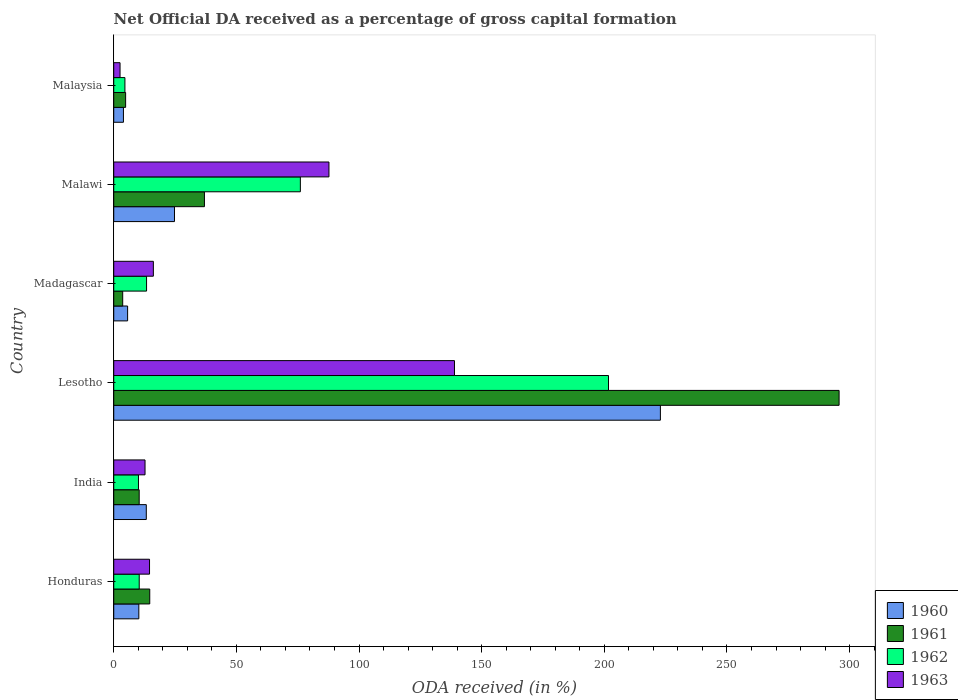How many groups of bars are there?
Your response must be concise. 6. Are the number of bars per tick equal to the number of legend labels?
Keep it short and to the point. Yes. How many bars are there on the 2nd tick from the top?
Provide a short and direct response. 4. What is the label of the 3rd group of bars from the top?
Your answer should be very brief. Madagascar. What is the net ODA received in 1962 in Malawi?
Provide a short and direct response. 76.08. Across all countries, what is the maximum net ODA received in 1963?
Provide a succinct answer. 138.92. Across all countries, what is the minimum net ODA received in 1961?
Make the answer very short. 3.65. In which country was the net ODA received in 1962 maximum?
Give a very brief answer. Lesotho. In which country was the net ODA received in 1961 minimum?
Ensure brevity in your answer.  Madagascar. What is the total net ODA received in 1960 in the graph?
Keep it short and to the point. 280.72. What is the difference between the net ODA received in 1960 in Lesotho and that in Malaysia?
Give a very brief answer. 218.91. What is the difference between the net ODA received in 1962 in Malaysia and the net ODA received in 1960 in Lesotho?
Your answer should be compact. -218.3. What is the average net ODA received in 1962 per country?
Offer a very short reply. 52.7. What is the difference between the net ODA received in 1961 and net ODA received in 1962 in Lesotho?
Offer a very short reply. 94.01. What is the ratio of the net ODA received in 1963 in Honduras to that in India?
Your response must be concise. 1.14. Is the net ODA received in 1962 in India less than that in Madagascar?
Provide a short and direct response. Yes. What is the difference between the highest and the second highest net ODA received in 1961?
Give a very brief answer. 258.74. What is the difference between the highest and the lowest net ODA received in 1960?
Make the answer very short. 218.91. Is the sum of the net ODA received in 1960 in Honduras and India greater than the maximum net ODA received in 1961 across all countries?
Make the answer very short. No. Is it the case that in every country, the sum of the net ODA received in 1961 and net ODA received in 1962 is greater than the sum of net ODA received in 1960 and net ODA received in 1963?
Provide a succinct answer. No. Is it the case that in every country, the sum of the net ODA received in 1962 and net ODA received in 1961 is greater than the net ODA received in 1963?
Offer a very short reply. Yes. How many countries are there in the graph?
Make the answer very short. 6. Where does the legend appear in the graph?
Ensure brevity in your answer.  Bottom right. How many legend labels are there?
Keep it short and to the point. 4. How are the legend labels stacked?
Offer a terse response. Vertical. What is the title of the graph?
Provide a short and direct response. Net Official DA received as a percentage of gross capital formation. Does "1971" appear as one of the legend labels in the graph?
Your answer should be very brief. No. What is the label or title of the X-axis?
Make the answer very short. ODA received (in %). What is the label or title of the Y-axis?
Your answer should be compact. Country. What is the ODA received (in %) of 1960 in Honduras?
Give a very brief answer. 10.23. What is the ODA received (in %) in 1961 in Honduras?
Offer a very short reply. 14.68. What is the ODA received (in %) in 1962 in Honduras?
Make the answer very short. 10.39. What is the ODA received (in %) of 1963 in Honduras?
Your answer should be very brief. 14.59. What is the ODA received (in %) in 1960 in India?
Offer a terse response. 13.27. What is the ODA received (in %) in 1961 in India?
Ensure brevity in your answer.  10.37. What is the ODA received (in %) of 1962 in India?
Provide a short and direct response. 10.08. What is the ODA received (in %) of 1963 in India?
Provide a succinct answer. 12.76. What is the ODA received (in %) of 1960 in Lesotho?
Keep it short and to the point. 222.86. What is the ODA received (in %) in 1961 in Lesotho?
Ensure brevity in your answer.  295.71. What is the ODA received (in %) of 1962 in Lesotho?
Ensure brevity in your answer.  201.7. What is the ODA received (in %) of 1963 in Lesotho?
Your answer should be very brief. 138.92. What is the ODA received (in %) of 1960 in Madagascar?
Give a very brief answer. 5.66. What is the ODA received (in %) of 1961 in Madagascar?
Provide a short and direct response. 3.65. What is the ODA received (in %) in 1962 in Madagascar?
Provide a succinct answer. 13.38. What is the ODA received (in %) of 1963 in Madagascar?
Your answer should be compact. 16.15. What is the ODA received (in %) of 1960 in Malawi?
Your answer should be compact. 24.76. What is the ODA received (in %) of 1961 in Malawi?
Offer a terse response. 36.97. What is the ODA received (in %) of 1962 in Malawi?
Your answer should be very brief. 76.08. What is the ODA received (in %) in 1963 in Malawi?
Provide a short and direct response. 87.74. What is the ODA received (in %) in 1960 in Malaysia?
Provide a succinct answer. 3.95. What is the ODA received (in %) of 1961 in Malaysia?
Your answer should be compact. 4.84. What is the ODA received (in %) in 1962 in Malaysia?
Offer a terse response. 4.56. What is the ODA received (in %) of 1963 in Malaysia?
Your answer should be very brief. 2.57. Across all countries, what is the maximum ODA received (in %) in 1960?
Your response must be concise. 222.86. Across all countries, what is the maximum ODA received (in %) in 1961?
Provide a short and direct response. 295.71. Across all countries, what is the maximum ODA received (in %) in 1962?
Offer a very short reply. 201.7. Across all countries, what is the maximum ODA received (in %) of 1963?
Give a very brief answer. 138.92. Across all countries, what is the minimum ODA received (in %) of 1960?
Your response must be concise. 3.95. Across all countries, what is the minimum ODA received (in %) of 1961?
Ensure brevity in your answer.  3.65. Across all countries, what is the minimum ODA received (in %) of 1962?
Ensure brevity in your answer.  4.56. Across all countries, what is the minimum ODA received (in %) of 1963?
Keep it short and to the point. 2.57. What is the total ODA received (in %) in 1960 in the graph?
Make the answer very short. 280.72. What is the total ODA received (in %) in 1961 in the graph?
Your answer should be very brief. 366.23. What is the total ODA received (in %) in 1962 in the graph?
Your response must be concise. 316.19. What is the total ODA received (in %) in 1963 in the graph?
Make the answer very short. 272.73. What is the difference between the ODA received (in %) in 1960 in Honduras and that in India?
Keep it short and to the point. -3.05. What is the difference between the ODA received (in %) in 1961 in Honduras and that in India?
Provide a short and direct response. 4.3. What is the difference between the ODA received (in %) of 1962 in Honduras and that in India?
Make the answer very short. 0.31. What is the difference between the ODA received (in %) in 1963 in Honduras and that in India?
Your response must be concise. 1.84. What is the difference between the ODA received (in %) in 1960 in Honduras and that in Lesotho?
Offer a very short reply. -212.63. What is the difference between the ODA received (in %) in 1961 in Honduras and that in Lesotho?
Keep it short and to the point. -281.04. What is the difference between the ODA received (in %) of 1962 in Honduras and that in Lesotho?
Provide a short and direct response. -191.31. What is the difference between the ODA received (in %) of 1963 in Honduras and that in Lesotho?
Your answer should be very brief. -124.33. What is the difference between the ODA received (in %) in 1960 in Honduras and that in Madagascar?
Your answer should be compact. 4.57. What is the difference between the ODA received (in %) in 1961 in Honduras and that in Madagascar?
Your answer should be compact. 11.03. What is the difference between the ODA received (in %) in 1962 in Honduras and that in Madagascar?
Provide a succinct answer. -2.99. What is the difference between the ODA received (in %) in 1963 in Honduras and that in Madagascar?
Give a very brief answer. -1.56. What is the difference between the ODA received (in %) in 1960 in Honduras and that in Malawi?
Give a very brief answer. -14.54. What is the difference between the ODA received (in %) of 1961 in Honduras and that in Malawi?
Make the answer very short. -22.29. What is the difference between the ODA received (in %) in 1962 in Honduras and that in Malawi?
Give a very brief answer. -65.69. What is the difference between the ODA received (in %) in 1963 in Honduras and that in Malawi?
Your answer should be compact. -73.15. What is the difference between the ODA received (in %) of 1960 in Honduras and that in Malaysia?
Your answer should be very brief. 6.27. What is the difference between the ODA received (in %) of 1961 in Honduras and that in Malaysia?
Provide a short and direct response. 9.83. What is the difference between the ODA received (in %) of 1962 in Honduras and that in Malaysia?
Make the answer very short. 5.83. What is the difference between the ODA received (in %) of 1963 in Honduras and that in Malaysia?
Provide a short and direct response. 12.02. What is the difference between the ODA received (in %) of 1960 in India and that in Lesotho?
Ensure brevity in your answer.  -209.59. What is the difference between the ODA received (in %) of 1961 in India and that in Lesotho?
Give a very brief answer. -285.34. What is the difference between the ODA received (in %) in 1962 in India and that in Lesotho?
Keep it short and to the point. -191.62. What is the difference between the ODA received (in %) in 1963 in India and that in Lesotho?
Make the answer very short. -126.16. What is the difference between the ODA received (in %) in 1960 in India and that in Madagascar?
Give a very brief answer. 7.62. What is the difference between the ODA received (in %) in 1961 in India and that in Madagascar?
Provide a succinct answer. 6.72. What is the difference between the ODA received (in %) of 1962 in India and that in Madagascar?
Provide a succinct answer. -3.3. What is the difference between the ODA received (in %) of 1963 in India and that in Madagascar?
Make the answer very short. -3.4. What is the difference between the ODA received (in %) in 1960 in India and that in Malawi?
Your response must be concise. -11.49. What is the difference between the ODA received (in %) of 1961 in India and that in Malawi?
Provide a succinct answer. -26.6. What is the difference between the ODA received (in %) of 1962 in India and that in Malawi?
Keep it short and to the point. -66. What is the difference between the ODA received (in %) in 1963 in India and that in Malawi?
Your answer should be compact. -74.98. What is the difference between the ODA received (in %) in 1960 in India and that in Malaysia?
Your response must be concise. 9.32. What is the difference between the ODA received (in %) of 1961 in India and that in Malaysia?
Provide a succinct answer. 5.53. What is the difference between the ODA received (in %) in 1962 in India and that in Malaysia?
Make the answer very short. 5.52. What is the difference between the ODA received (in %) of 1963 in India and that in Malaysia?
Ensure brevity in your answer.  10.19. What is the difference between the ODA received (in %) of 1960 in Lesotho and that in Madagascar?
Offer a very short reply. 217.2. What is the difference between the ODA received (in %) of 1961 in Lesotho and that in Madagascar?
Offer a very short reply. 292.06. What is the difference between the ODA received (in %) in 1962 in Lesotho and that in Madagascar?
Offer a terse response. 188.32. What is the difference between the ODA received (in %) in 1963 in Lesotho and that in Madagascar?
Provide a short and direct response. 122.76. What is the difference between the ODA received (in %) in 1960 in Lesotho and that in Malawi?
Your answer should be very brief. 198.1. What is the difference between the ODA received (in %) in 1961 in Lesotho and that in Malawi?
Make the answer very short. 258.74. What is the difference between the ODA received (in %) in 1962 in Lesotho and that in Malawi?
Give a very brief answer. 125.62. What is the difference between the ODA received (in %) of 1963 in Lesotho and that in Malawi?
Ensure brevity in your answer.  51.18. What is the difference between the ODA received (in %) of 1960 in Lesotho and that in Malaysia?
Provide a short and direct response. 218.91. What is the difference between the ODA received (in %) in 1961 in Lesotho and that in Malaysia?
Provide a short and direct response. 290.87. What is the difference between the ODA received (in %) of 1962 in Lesotho and that in Malaysia?
Offer a terse response. 197.14. What is the difference between the ODA received (in %) in 1963 in Lesotho and that in Malaysia?
Offer a very short reply. 136.35. What is the difference between the ODA received (in %) in 1960 in Madagascar and that in Malawi?
Provide a short and direct response. -19.11. What is the difference between the ODA received (in %) in 1961 in Madagascar and that in Malawi?
Offer a terse response. -33.32. What is the difference between the ODA received (in %) in 1962 in Madagascar and that in Malawi?
Provide a short and direct response. -62.7. What is the difference between the ODA received (in %) in 1963 in Madagascar and that in Malawi?
Ensure brevity in your answer.  -71.59. What is the difference between the ODA received (in %) of 1960 in Madagascar and that in Malaysia?
Ensure brevity in your answer.  1.7. What is the difference between the ODA received (in %) in 1961 in Madagascar and that in Malaysia?
Provide a succinct answer. -1.19. What is the difference between the ODA received (in %) in 1962 in Madagascar and that in Malaysia?
Give a very brief answer. 8.82. What is the difference between the ODA received (in %) of 1963 in Madagascar and that in Malaysia?
Your answer should be very brief. 13.59. What is the difference between the ODA received (in %) in 1960 in Malawi and that in Malaysia?
Offer a very short reply. 20.81. What is the difference between the ODA received (in %) in 1961 in Malawi and that in Malaysia?
Give a very brief answer. 32.13. What is the difference between the ODA received (in %) in 1962 in Malawi and that in Malaysia?
Your answer should be very brief. 71.52. What is the difference between the ODA received (in %) of 1963 in Malawi and that in Malaysia?
Your answer should be compact. 85.17. What is the difference between the ODA received (in %) of 1960 in Honduras and the ODA received (in %) of 1961 in India?
Offer a terse response. -0.15. What is the difference between the ODA received (in %) of 1960 in Honduras and the ODA received (in %) of 1962 in India?
Your answer should be very brief. 0.14. What is the difference between the ODA received (in %) in 1960 in Honduras and the ODA received (in %) in 1963 in India?
Your answer should be very brief. -2.53. What is the difference between the ODA received (in %) of 1961 in Honduras and the ODA received (in %) of 1962 in India?
Offer a terse response. 4.6. What is the difference between the ODA received (in %) of 1961 in Honduras and the ODA received (in %) of 1963 in India?
Offer a very short reply. 1.92. What is the difference between the ODA received (in %) in 1962 in Honduras and the ODA received (in %) in 1963 in India?
Your answer should be very brief. -2.37. What is the difference between the ODA received (in %) in 1960 in Honduras and the ODA received (in %) in 1961 in Lesotho?
Give a very brief answer. -285.49. What is the difference between the ODA received (in %) of 1960 in Honduras and the ODA received (in %) of 1962 in Lesotho?
Offer a terse response. -191.48. What is the difference between the ODA received (in %) in 1960 in Honduras and the ODA received (in %) in 1963 in Lesotho?
Give a very brief answer. -128.69. What is the difference between the ODA received (in %) in 1961 in Honduras and the ODA received (in %) in 1962 in Lesotho?
Provide a short and direct response. -187.02. What is the difference between the ODA received (in %) of 1961 in Honduras and the ODA received (in %) of 1963 in Lesotho?
Your answer should be very brief. -124.24. What is the difference between the ODA received (in %) of 1962 in Honduras and the ODA received (in %) of 1963 in Lesotho?
Provide a succinct answer. -128.53. What is the difference between the ODA received (in %) in 1960 in Honduras and the ODA received (in %) in 1961 in Madagascar?
Provide a succinct answer. 6.57. What is the difference between the ODA received (in %) in 1960 in Honduras and the ODA received (in %) in 1962 in Madagascar?
Your answer should be compact. -3.16. What is the difference between the ODA received (in %) of 1960 in Honduras and the ODA received (in %) of 1963 in Madagascar?
Your response must be concise. -5.93. What is the difference between the ODA received (in %) in 1961 in Honduras and the ODA received (in %) in 1962 in Madagascar?
Ensure brevity in your answer.  1.3. What is the difference between the ODA received (in %) in 1961 in Honduras and the ODA received (in %) in 1963 in Madagascar?
Keep it short and to the point. -1.48. What is the difference between the ODA received (in %) in 1962 in Honduras and the ODA received (in %) in 1963 in Madagascar?
Provide a short and direct response. -5.76. What is the difference between the ODA received (in %) in 1960 in Honduras and the ODA received (in %) in 1961 in Malawi?
Keep it short and to the point. -26.75. What is the difference between the ODA received (in %) in 1960 in Honduras and the ODA received (in %) in 1962 in Malawi?
Ensure brevity in your answer.  -65.86. What is the difference between the ODA received (in %) in 1960 in Honduras and the ODA received (in %) in 1963 in Malawi?
Your answer should be compact. -77.51. What is the difference between the ODA received (in %) of 1961 in Honduras and the ODA received (in %) of 1962 in Malawi?
Give a very brief answer. -61.4. What is the difference between the ODA received (in %) in 1961 in Honduras and the ODA received (in %) in 1963 in Malawi?
Offer a terse response. -73.06. What is the difference between the ODA received (in %) in 1962 in Honduras and the ODA received (in %) in 1963 in Malawi?
Provide a short and direct response. -77.35. What is the difference between the ODA received (in %) in 1960 in Honduras and the ODA received (in %) in 1961 in Malaysia?
Ensure brevity in your answer.  5.38. What is the difference between the ODA received (in %) of 1960 in Honduras and the ODA received (in %) of 1962 in Malaysia?
Offer a very short reply. 5.66. What is the difference between the ODA received (in %) in 1960 in Honduras and the ODA received (in %) in 1963 in Malaysia?
Ensure brevity in your answer.  7.66. What is the difference between the ODA received (in %) of 1961 in Honduras and the ODA received (in %) of 1962 in Malaysia?
Provide a succinct answer. 10.12. What is the difference between the ODA received (in %) of 1961 in Honduras and the ODA received (in %) of 1963 in Malaysia?
Make the answer very short. 12.11. What is the difference between the ODA received (in %) of 1962 in Honduras and the ODA received (in %) of 1963 in Malaysia?
Your response must be concise. 7.82. What is the difference between the ODA received (in %) of 1960 in India and the ODA received (in %) of 1961 in Lesotho?
Your answer should be very brief. -282.44. What is the difference between the ODA received (in %) in 1960 in India and the ODA received (in %) in 1962 in Lesotho?
Give a very brief answer. -188.43. What is the difference between the ODA received (in %) of 1960 in India and the ODA received (in %) of 1963 in Lesotho?
Provide a short and direct response. -125.65. What is the difference between the ODA received (in %) in 1961 in India and the ODA received (in %) in 1962 in Lesotho?
Make the answer very short. -191.33. What is the difference between the ODA received (in %) of 1961 in India and the ODA received (in %) of 1963 in Lesotho?
Give a very brief answer. -128.54. What is the difference between the ODA received (in %) in 1962 in India and the ODA received (in %) in 1963 in Lesotho?
Offer a very short reply. -128.84. What is the difference between the ODA received (in %) in 1960 in India and the ODA received (in %) in 1961 in Madagascar?
Provide a succinct answer. 9.62. What is the difference between the ODA received (in %) in 1960 in India and the ODA received (in %) in 1962 in Madagascar?
Ensure brevity in your answer.  -0.11. What is the difference between the ODA received (in %) in 1960 in India and the ODA received (in %) in 1963 in Madagascar?
Give a very brief answer. -2.88. What is the difference between the ODA received (in %) of 1961 in India and the ODA received (in %) of 1962 in Madagascar?
Make the answer very short. -3.01. What is the difference between the ODA received (in %) in 1961 in India and the ODA received (in %) in 1963 in Madagascar?
Ensure brevity in your answer.  -5.78. What is the difference between the ODA received (in %) of 1962 in India and the ODA received (in %) of 1963 in Madagascar?
Provide a succinct answer. -6.07. What is the difference between the ODA received (in %) of 1960 in India and the ODA received (in %) of 1961 in Malawi?
Ensure brevity in your answer.  -23.7. What is the difference between the ODA received (in %) in 1960 in India and the ODA received (in %) in 1962 in Malawi?
Your answer should be compact. -62.81. What is the difference between the ODA received (in %) of 1960 in India and the ODA received (in %) of 1963 in Malawi?
Your response must be concise. -74.47. What is the difference between the ODA received (in %) of 1961 in India and the ODA received (in %) of 1962 in Malawi?
Your answer should be very brief. -65.71. What is the difference between the ODA received (in %) in 1961 in India and the ODA received (in %) in 1963 in Malawi?
Make the answer very short. -77.37. What is the difference between the ODA received (in %) of 1962 in India and the ODA received (in %) of 1963 in Malawi?
Offer a terse response. -77.66. What is the difference between the ODA received (in %) of 1960 in India and the ODA received (in %) of 1961 in Malaysia?
Ensure brevity in your answer.  8.43. What is the difference between the ODA received (in %) of 1960 in India and the ODA received (in %) of 1962 in Malaysia?
Your answer should be very brief. 8.71. What is the difference between the ODA received (in %) of 1960 in India and the ODA received (in %) of 1963 in Malaysia?
Your answer should be very brief. 10.7. What is the difference between the ODA received (in %) in 1961 in India and the ODA received (in %) in 1962 in Malaysia?
Your answer should be very brief. 5.81. What is the difference between the ODA received (in %) in 1961 in India and the ODA received (in %) in 1963 in Malaysia?
Ensure brevity in your answer.  7.8. What is the difference between the ODA received (in %) of 1962 in India and the ODA received (in %) of 1963 in Malaysia?
Make the answer very short. 7.51. What is the difference between the ODA received (in %) in 1960 in Lesotho and the ODA received (in %) in 1961 in Madagascar?
Ensure brevity in your answer.  219.21. What is the difference between the ODA received (in %) in 1960 in Lesotho and the ODA received (in %) in 1962 in Madagascar?
Your answer should be very brief. 209.48. What is the difference between the ODA received (in %) in 1960 in Lesotho and the ODA received (in %) in 1963 in Madagascar?
Your answer should be very brief. 206.7. What is the difference between the ODA received (in %) of 1961 in Lesotho and the ODA received (in %) of 1962 in Madagascar?
Provide a succinct answer. 282.33. What is the difference between the ODA received (in %) in 1961 in Lesotho and the ODA received (in %) in 1963 in Madagascar?
Make the answer very short. 279.56. What is the difference between the ODA received (in %) in 1962 in Lesotho and the ODA received (in %) in 1963 in Madagascar?
Your answer should be compact. 185.55. What is the difference between the ODA received (in %) of 1960 in Lesotho and the ODA received (in %) of 1961 in Malawi?
Give a very brief answer. 185.89. What is the difference between the ODA received (in %) of 1960 in Lesotho and the ODA received (in %) of 1962 in Malawi?
Your response must be concise. 146.78. What is the difference between the ODA received (in %) of 1960 in Lesotho and the ODA received (in %) of 1963 in Malawi?
Offer a very short reply. 135.12. What is the difference between the ODA received (in %) of 1961 in Lesotho and the ODA received (in %) of 1962 in Malawi?
Provide a short and direct response. 219.63. What is the difference between the ODA received (in %) in 1961 in Lesotho and the ODA received (in %) in 1963 in Malawi?
Make the answer very short. 207.97. What is the difference between the ODA received (in %) of 1962 in Lesotho and the ODA received (in %) of 1963 in Malawi?
Offer a terse response. 113.96. What is the difference between the ODA received (in %) of 1960 in Lesotho and the ODA received (in %) of 1961 in Malaysia?
Provide a short and direct response. 218.01. What is the difference between the ODA received (in %) in 1960 in Lesotho and the ODA received (in %) in 1962 in Malaysia?
Offer a very short reply. 218.3. What is the difference between the ODA received (in %) in 1960 in Lesotho and the ODA received (in %) in 1963 in Malaysia?
Keep it short and to the point. 220.29. What is the difference between the ODA received (in %) in 1961 in Lesotho and the ODA received (in %) in 1962 in Malaysia?
Provide a succinct answer. 291.15. What is the difference between the ODA received (in %) of 1961 in Lesotho and the ODA received (in %) of 1963 in Malaysia?
Your answer should be very brief. 293.15. What is the difference between the ODA received (in %) of 1962 in Lesotho and the ODA received (in %) of 1963 in Malaysia?
Make the answer very short. 199.13. What is the difference between the ODA received (in %) in 1960 in Madagascar and the ODA received (in %) in 1961 in Malawi?
Offer a very short reply. -31.32. What is the difference between the ODA received (in %) of 1960 in Madagascar and the ODA received (in %) of 1962 in Malawi?
Provide a short and direct response. -70.43. What is the difference between the ODA received (in %) in 1960 in Madagascar and the ODA received (in %) in 1963 in Malawi?
Offer a terse response. -82.08. What is the difference between the ODA received (in %) in 1961 in Madagascar and the ODA received (in %) in 1962 in Malawi?
Your answer should be compact. -72.43. What is the difference between the ODA received (in %) of 1961 in Madagascar and the ODA received (in %) of 1963 in Malawi?
Your response must be concise. -84.09. What is the difference between the ODA received (in %) in 1962 in Madagascar and the ODA received (in %) in 1963 in Malawi?
Your answer should be very brief. -74.36. What is the difference between the ODA received (in %) in 1960 in Madagascar and the ODA received (in %) in 1961 in Malaysia?
Provide a succinct answer. 0.81. What is the difference between the ODA received (in %) of 1960 in Madagascar and the ODA received (in %) of 1962 in Malaysia?
Your answer should be very brief. 1.09. What is the difference between the ODA received (in %) of 1960 in Madagascar and the ODA received (in %) of 1963 in Malaysia?
Offer a terse response. 3.09. What is the difference between the ODA received (in %) in 1961 in Madagascar and the ODA received (in %) in 1962 in Malaysia?
Provide a succinct answer. -0.91. What is the difference between the ODA received (in %) of 1961 in Madagascar and the ODA received (in %) of 1963 in Malaysia?
Your answer should be very brief. 1.08. What is the difference between the ODA received (in %) in 1962 in Madagascar and the ODA received (in %) in 1963 in Malaysia?
Keep it short and to the point. 10.81. What is the difference between the ODA received (in %) in 1960 in Malawi and the ODA received (in %) in 1961 in Malaysia?
Offer a very short reply. 19.92. What is the difference between the ODA received (in %) in 1960 in Malawi and the ODA received (in %) in 1962 in Malaysia?
Ensure brevity in your answer.  20.2. What is the difference between the ODA received (in %) of 1960 in Malawi and the ODA received (in %) of 1963 in Malaysia?
Your response must be concise. 22.19. What is the difference between the ODA received (in %) in 1961 in Malawi and the ODA received (in %) in 1962 in Malaysia?
Your response must be concise. 32.41. What is the difference between the ODA received (in %) in 1961 in Malawi and the ODA received (in %) in 1963 in Malaysia?
Make the answer very short. 34.4. What is the difference between the ODA received (in %) of 1962 in Malawi and the ODA received (in %) of 1963 in Malaysia?
Ensure brevity in your answer.  73.51. What is the average ODA received (in %) in 1960 per country?
Keep it short and to the point. 46.79. What is the average ODA received (in %) in 1961 per country?
Keep it short and to the point. 61.04. What is the average ODA received (in %) in 1962 per country?
Provide a short and direct response. 52.7. What is the average ODA received (in %) in 1963 per country?
Make the answer very short. 45.45. What is the difference between the ODA received (in %) of 1960 and ODA received (in %) of 1961 in Honduras?
Keep it short and to the point. -4.45. What is the difference between the ODA received (in %) of 1960 and ODA received (in %) of 1962 in Honduras?
Keep it short and to the point. -0.16. What is the difference between the ODA received (in %) of 1960 and ODA received (in %) of 1963 in Honduras?
Your answer should be very brief. -4.37. What is the difference between the ODA received (in %) in 1961 and ODA received (in %) in 1962 in Honduras?
Your answer should be compact. 4.29. What is the difference between the ODA received (in %) of 1961 and ODA received (in %) of 1963 in Honduras?
Provide a short and direct response. 0.09. What is the difference between the ODA received (in %) of 1962 and ODA received (in %) of 1963 in Honduras?
Your answer should be compact. -4.2. What is the difference between the ODA received (in %) of 1960 and ODA received (in %) of 1961 in India?
Offer a very short reply. 2.9. What is the difference between the ODA received (in %) in 1960 and ODA received (in %) in 1962 in India?
Keep it short and to the point. 3.19. What is the difference between the ODA received (in %) in 1960 and ODA received (in %) in 1963 in India?
Ensure brevity in your answer.  0.52. What is the difference between the ODA received (in %) of 1961 and ODA received (in %) of 1962 in India?
Provide a succinct answer. 0.29. What is the difference between the ODA received (in %) in 1961 and ODA received (in %) in 1963 in India?
Your answer should be compact. -2.38. What is the difference between the ODA received (in %) in 1962 and ODA received (in %) in 1963 in India?
Your answer should be compact. -2.68. What is the difference between the ODA received (in %) in 1960 and ODA received (in %) in 1961 in Lesotho?
Your response must be concise. -72.86. What is the difference between the ODA received (in %) of 1960 and ODA received (in %) of 1962 in Lesotho?
Ensure brevity in your answer.  21.16. What is the difference between the ODA received (in %) in 1960 and ODA received (in %) in 1963 in Lesotho?
Offer a very short reply. 83.94. What is the difference between the ODA received (in %) in 1961 and ODA received (in %) in 1962 in Lesotho?
Provide a succinct answer. 94.01. What is the difference between the ODA received (in %) of 1961 and ODA received (in %) of 1963 in Lesotho?
Provide a succinct answer. 156.8. What is the difference between the ODA received (in %) of 1962 and ODA received (in %) of 1963 in Lesotho?
Give a very brief answer. 62.78. What is the difference between the ODA received (in %) of 1960 and ODA received (in %) of 1961 in Madagascar?
Give a very brief answer. 2. What is the difference between the ODA received (in %) in 1960 and ODA received (in %) in 1962 in Madagascar?
Keep it short and to the point. -7.72. What is the difference between the ODA received (in %) of 1960 and ODA received (in %) of 1963 in Madagascar?
Offer a terse response. -10.5. What is the difference between the ODA received (in %) of 1961 and ODA received (in %) of 1962 in Madagascar?
Your answer should be compact. -9.73. What is the difference between the ODA received (in %) of 1961 and ODA received (in %) of 1963 in Madagascar?
Provide a short and direct response. -12.5. What is the difference between the ODA received (in %) in 1962 and ODA received (in %) in 1963 in Madagascar?
Keep it short and to the point. -2.77. What is the difference between the ODA received (in %) of 1960 and ODA received (in %) of 1961 in Malawi?
Offer a very short reply. -12.21. What is the difference between the ODA received (in %) of 1960 and ODA received (in %) of 1962 in Malawi?
Ensure brevity in your answer.  -51.32. What is the difference between the ODA received (in %) of 1960 and ODA received (in %) of 1963 in Malawi?
Offer a very short reply. -62.98. What is the difference between the ODA received (in %) of 1961 and ODA received (in %) of 1962 in Malawi?
Give a very brief answer. -39.11. What is the difference between the ODA received (in %) of 1961 and ODA received (in %) of 1963 in Malawi?
Keep it short and to the point. -50.77. What is the difference between the ODA received (in %) of 1962 and ODA received (in %) of 1963 in Malawi?
Provide a succinct answer. -11.66. What is the difference between the ODA received (in %) in 1960 and ODA received (in %) in 1961 in Malaysia?
Make the answer very short. -0.89. What is the difference between the ODA received (in %) of 1960 and ODA received (in %) of 1962 in Malaysia?
Ensure brevity in your answer.  -0.61. What is the difference between the ODA received (in %) of 1960 and ODA received (in %) of 1963 in Malaysia?
Give a very brief answer. 1.38. What is the difference between the ODA received (in %) of 1961 and ODA received (in %) of 1962 in Malaysia?
Offer a very short reply. 0.28. What is the difference between the ODA received (in %) of 1961 and ODA received (in %) of 1963 in Malaysia?
Ensure brevity in your answer.  2.28. What is the difference between the ODA received (in %) of 1962 and ODA received (in %) of 1963 in Malaysia?
Your answer should be compact. 1.99. What is the ratio of the ODA received (in %) of 1960 in Honduras to that in India?
Your response must be concise. 0.77. What is the ratio of the ODA received (in %) of 1961 in Honduras to that in India?
Ensure brevity in your answer.  1.41. What is the ratio of the ODA received (in %) of 1962 in Honduras to that in India?
Keep it short and to the point. 1.03. What is the ratio of the ODA received (in %) of 1963 in Honduras to that in India?
Make the answer very short. 1.14. What is the ratio of the ODA received (in %) of 1960 in Honduras to that in Lesotho?
Provide a short and direct response. 0.05. What is the ratio of the ODA received (in %) of 1961 in Honduras to that in Lesotho?
Make the answer very short. 0.05. What is the ratio of the ODA received (in %) of 1962 in Honduras to that in Lesotho?
Make the answer very short. 0.05. What is the ratio of the ODA received (in %) in 1963 in Honduras to that in Lesotho?
Keep it short and to the point. 0.1. What is the ratio of the ODA received (in %) in 1960 in Honduras to that in Madagascar?
Make the answer very short. 1.81. What is the ratio of the ODA received (in %) in 1961 in Honduras to that in Madagascar?
Give a very brief answer. 4.02. What is the ratio of the ODA received (in %) of 1962 in Honduras to that in Madagascar?
Provide a succinct answer. 0.78. What is the ratio of the ODA received (in %) of 1963 in Honduras to that in Madagascar?
Provide a succinct answer. 0.9. What is the ratio of the ODA received (in %) in 1960 in Honduras to that in Malawi?
Provide a short and direct response. 0.41. What is the ratio of the ODA received (in %) of 1961 in Honduras to that in Malawi?
Your response must be concise. 0.4. What is the ratio of the ODA received (in %) in 1962 in Honduras to that in Malawi?
Your answer should be very brief. 0.14. What is the ratio of the ODA received (in %) in 1963 in Honduras to that in Malawi?
Your response must be concise. 0.17. What is the ratio of the ODA received (in %) in 1960 in Honduras to that in Malaysia?
Offer a terse response. 2.59. What is the ratio of the ODA received (in %) of 1961 in Honduras to that in Malaysia?
Provide a succinct answer. 3.03. What is the ratio of the ODA received (in %) of 1962 in Honduras to that in Malaysia?
Keep it short and to the point. 2.28. What is the ratio of the ODA received (in %) in 1963 in Honduras to that in Malaysia?
Your answer should be compact. 5.68. What is the ratio of the ODA received (in %) of 1960 in India to that in Lesotho?
Ensure brevity in your answer.  0.06. What is the ratio of the ODA received (in %) in 1961 in India to that in Lesotho?
Ensure brevity in your answer.  0.04. What is the ratio of the ODA received (in %) of 1962 in India to that in Lesotho?
Offer a very short reply. 0.05. What is the ratio of the ODA received (in %) in 1963 in India to that in Lesotho?
Provide a succinct answer. 0.09. What is the ratio of the ODA received (in %) of 1960 in India to that in Madagascar?
Your answer should be compact. 2.35. What is the ratio of the ODA received (in %) in 1961 in India to that in Madagascar?
Provide a short and direct response. 2.84. What is the ratio of the ODA received (in %) in 1962 in India to that in Madagascar?
Your answer should be very brief. 0.75. What is the ratio of the ODA received (in %) in 1963 in India to that in Madagascar?
Your answer should be very brief. 0.79. What is the ratio of the ODA received (in %) of 1960 in India to that in Malawi?
Provide a short and direct response. 0.54. What is the ratio of the ODA received (in %) of 1961 in India to that in Malawi?
Provide a short and direct response. 0.28. What is the ratio of the ODA received (in %) of 1962 in India to that in Malawi?
Provide a short and direct response. 0.13. What is the ratio of the ODA received (in %) of 1963 in India to that in Malawi?
Ensure brevity in your answer.  0.15. What is the ratio of the ODA received (in %) of 1960 in India to that in Malaysia?
Provide a short and direct response. 3.36. What is the ratio of the ODA received (in %) in 1961 in India to that in Malaysia?
Your response must be concise. 2.14. What is the ratio of the ODA received (in %) of 1962 in India to that in Malaysia?
Ensure brevity in your answer.  2.21. What is the ratio of the ODA received (in %) of 1963 in India to that in Malaysia?
Ensure brevity in your answer.  4.97. What is the ratio of the ODA received (in %) of 1960 in Lesotho to that in Madagascar?
Your answer should be compact. 39.4. What is the ratio of the ODA received (in %) in 1961 in Lesotho to that in Madagascar?
Keep it short and to the point. 80.97. What is the ratio of the ODA received (in %) of 1962 in Lesotho to that in Madagascar?
Offer a very short reply. 15.07. What is the ratio of the ODA received (in %) of 1963 in Lesotho to that in Madagascar?
Give a very brief answer. 8.6. What is the ratio of the ODA received (in %) of 1961 in Lesotho to that in Malawi?
Provide a succinct answer. 8. What is the ratio of the ODA received (in %) in 1962 in Lesotho to that in Malawi?
Make the answer very short. 2.65. What is the ratio of the ODA received (in %) in 1963 in Lesotho to that in Malawi?
Provide a succinct answer. 1.58. What is the ratio of the ODA received (in %) in 1960 in Lesotho to that in Malaysia?
Give a very brief answer. 56.41. What is the ratio of the ODA received (in %) in 1961 in Lesotho to that in Malaysia?
Ensure brevity in your answer.  61.04. What is the ratio of the ODA received (in %) of 1962 in Lesotho to that in Malaysia?
Your answer should be very brief. 44.23. What is the ratio of the ODA received (in %) of 1963 in Lesotho to that in Malaysia?
Your answer should be very brief. 54.07. What is the ratio of the ODA received (in %) in 1960 in Madagascar to that in Malawi?
Provide a short and direct response. 0.23. What is the ratio of the ODA received (in %) of 1961 in Madagascar to that in Malawi?
Keep it short and to the point. 0.1. What is the ratio of the ODA received (in %) of 1962 in Madagascar to that in Malawi?
Make the answer very short. 0.18. What is the ratio of the ODA received (in %) in 1963 in Madagascar to that in Malawi?
Your answer should be very brief. 0.18. What is the ratio of the ODA received (in %) in 1960 in Madagascar to that in Malaysia?
Give a very brief answer. 1.43. What is the ratio of the ODA received (in %) in 1961 in Madagascar to that in Malaysia?
Give a very brief answer. 0.75. What is the ratio of the ODA received (in %) of 1962 in Madagascar to that in Malaysia?
Your answer should be compact. 2.93. What is the ratio of the ODA received (in %) of 1963 in Madagascar to that in Malaysia?
Give a very brief answer. 6.29. What is the ratio of the ODA received (in %) of 1960 in Malawi to that in Malaysia?
Your answer should be very brief. 6.27. What is the ratio of the ODA received (in %) in 1961 in Malawi to that in Malaysia?
Provide a succinct answer. 7.63. What is the ratio of the ODA received (in %) in 1962 in Malawi to that in Malaysia?
Give a very brief answer. 16.68. What is the ratio of the ODA received (in %) in 1963 in Malawi to that in Malaysia?
Ensure brevity in your answer.  34.15. What is the difference between the highest and the second highest ODA received (in %) of 1960?
Your answer should be very brief. 198.1. What is the difference between the highest and the second highest ODA received (in %) of 1961?
Provide a succinct answer. 258.74. What is the difference between the highest and the second highest ODA received (in %) of 1962?
Keep it short and to the point. 125.62. What is the difference between the highest and the second highest ODA received (in %) in 1963?
Provide a short and direct response. 51.18. What is the difference between the highest and the lowest ODA received (in %) of 1960?
Provide a short and direct response. 218.91. What is the difference between the highest and the lowest ODA received (in %) of 1961?
Offer a very short reply. 292.06. What is the difference between the highest and the lowest ODA received (in %) in 1962?
Your answer should be compact. 197.14. What is the difference between the highest and the lowest ODA received (in %) of 1963?
Give a very brief answer. 136.35. 